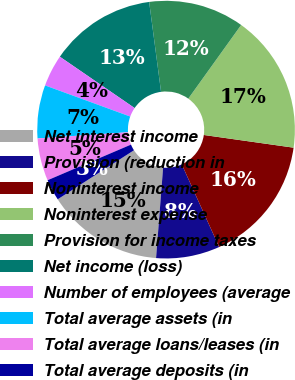<chart> <loc_0><loc_0><loc_500><loc_500><pie_chart><fcel>Net interest income<fcel>Provision (reduction in<fcel>Noninterest income<fcel>Noninterest expense<fcel>Provision for income taxes<fcel>Net income (loss)<fcel>Number of employees (average<fcel>Total average assets (in<fcel>Total average loans/leases (in<fcel>Total average deposits (in<nl><fcel>14.67%<fcel>8.0%<fcel>16.0%<fcel>17.33%<fcel>12.0%<fcel>13.33%<fcel>4.0%<fcel>6.67%<fcel>5.33%<fcel>2.67%<nl></chart> 